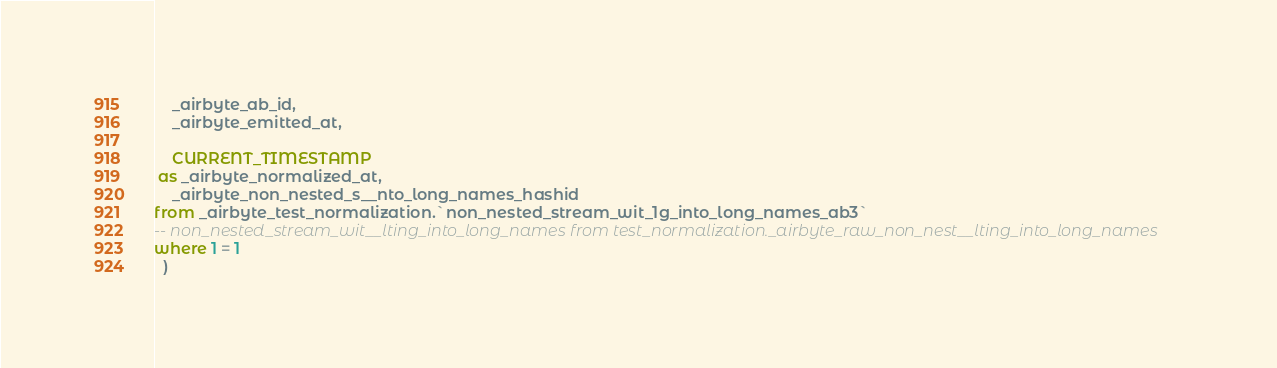<code> <loc_0><loc_0><loc_500><loc_500><_SQL_>    _airbyte_ab_id,
    _airbyte_emitted_at,
    
    CURRENT_TIMESTAMP
 as _airbyte_normalized_at,
    _airbyte_non_nested_s__nto_long_names_hashid
from _airbyte_test_normalization.`non_nested_stream_wit_1g_into_long_names_ab3`
-- non_nested_stream_wit__lting_into_long_names from test_normalization._airbyte_raw_non_nest__lting_into_long_names
where 1 = 1
  )
</code> 